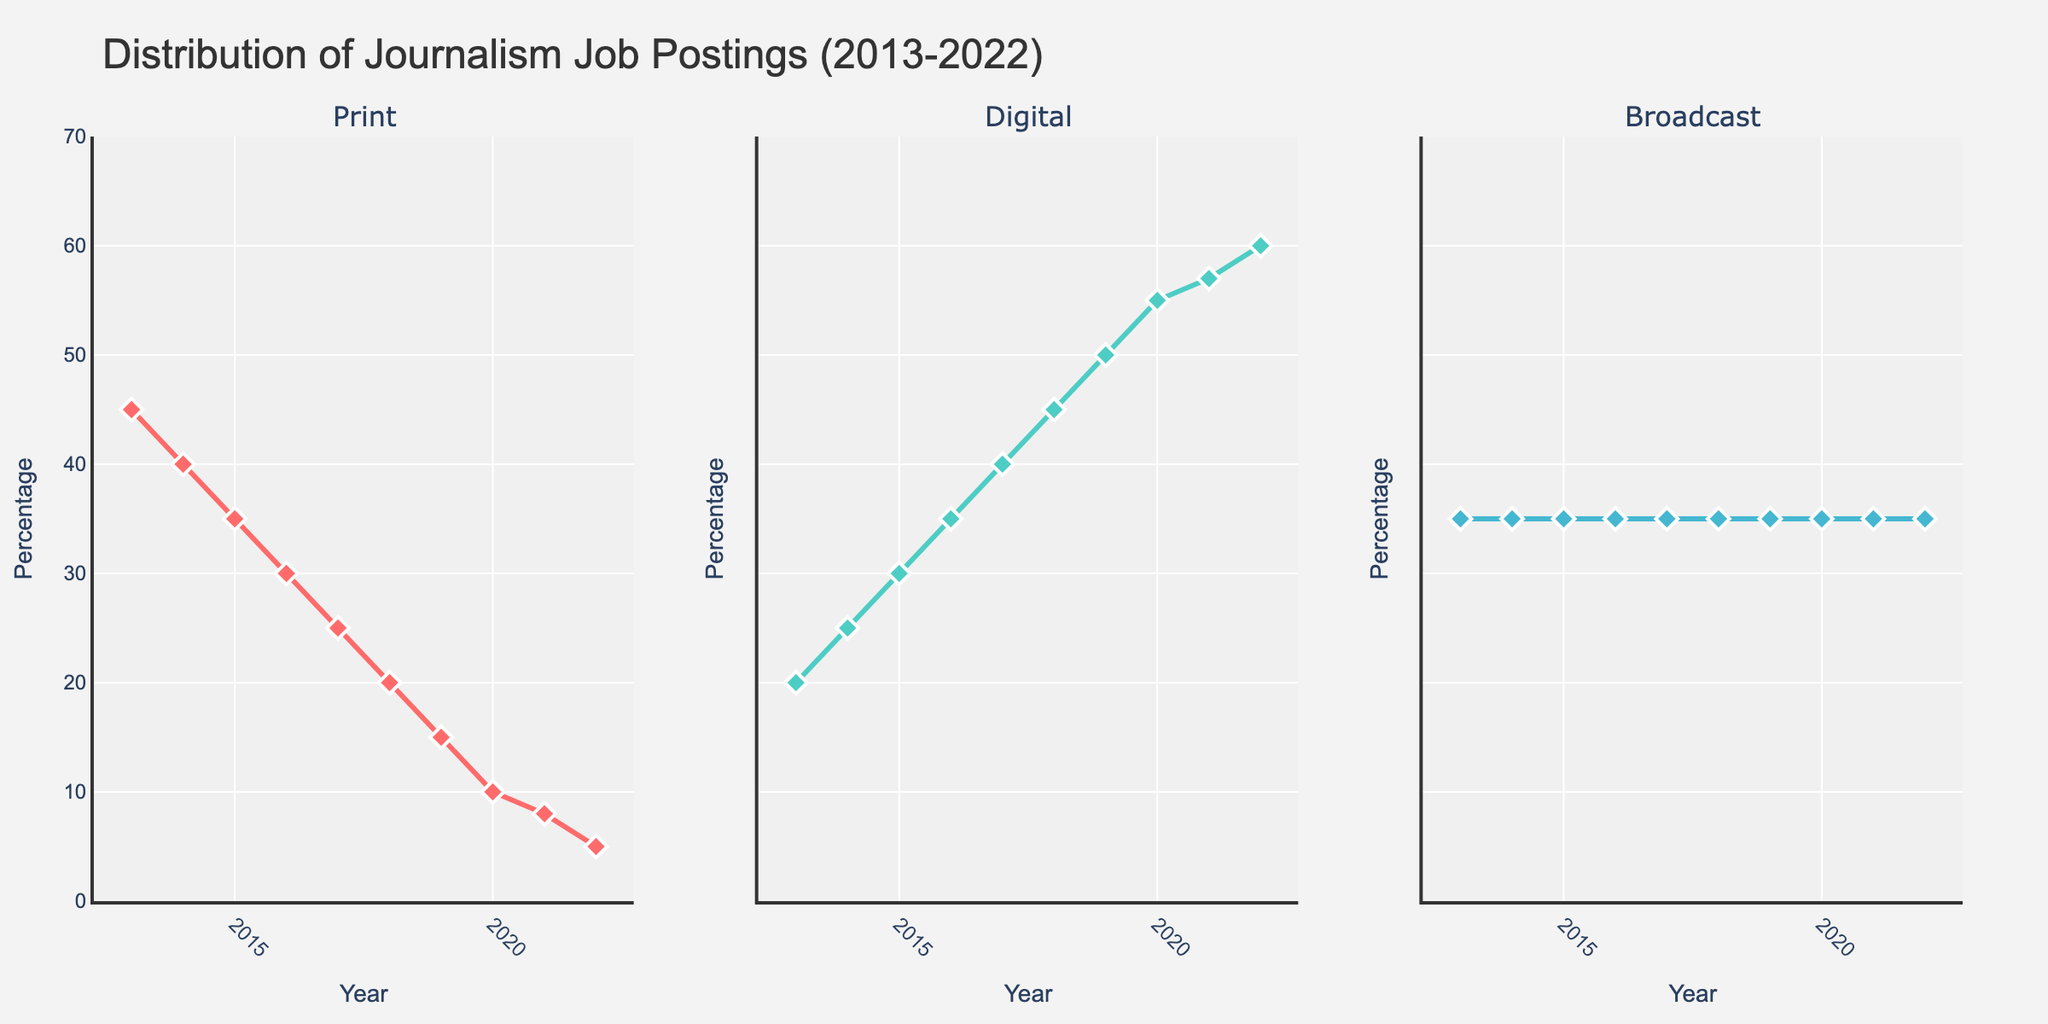When did the percentage of print journalism job postings start dropping below the percentage of digital journalism job postings? By observing the Print and Digital lines on the plot, the percentage of print job postings falls below digital job postings in 2015, where the trend crosses.
Answer: 2015 Which subplots have a consistent trend over the years? The broadcast subplot shows a consistent trend with a flat line at 35%, while the other two subplots have rising or falling trends.
Answer: Broadcast By how much did digital journalism job postings increase from 2013 to 2022? In the Digital subplot, the postings start at 20% in 2013 and rise to 60% in 2022. The difference is 60 - 20 = 40%.
Answer: 40% Which year recorded the lowest percentage for print journalism job postings? In the Print subplot, the lowest point is in 2022, where the percentage is marked at 5%.
Answer: 2022 How does the percentage of broadcast journalism job postings in 2020 compare to that in 2013? Both in 2013 and 2020, the broadcast journalism job postings are at 35%, indicating no change.
Answer: Equal What is the average percentage of print journalism job postings over the decade? The percentage values for print are 45, 40, 35, 30, 25, 20, 15, 10, 8, and 5. Summing these, 233, then dividing by 10 years gives 23.3%.
Answer: 23.3% Which media type had the largest increase in job postings from 2013 to 2022? Comparing the three plots, Digital increased from 20% to 60%, showing the largest change of 40%. Print decreased, and Broadcast stayed the same.
Answer: Digital How did the percentages of digital and print job postings in 2021 differ? In 2021, digital job postings were at 57%, while print was at 8%. The difference is 57 - 8 = 49%.
Answer: 49% What is the trend for digital journalism job postings over the past decade? The Digital subplot shows an upward trend, continuously increasing from 20% in 2013 to 60% in 2022.
Answer: Increasing 